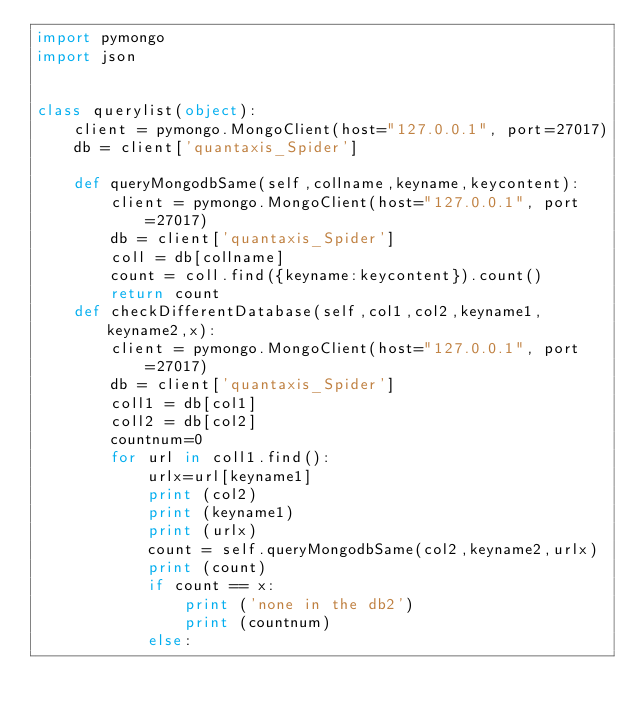<code> <loc_0><loc_0><loc_500><loc_500><_Python_>import pymongo
import json


class querylist(object):
    client = pymongo.MongoClient(host="127.0.0.1", port=27017)
    db = client['quantaxis_Spider']
    
    def queryMongodbSame(self,collname,keyname,keycontent):
        client = pymongo.MongoClient(host="127.0.0.1", port=27017)
        db = client['quantaxis_Spider']
        coll = db[collname]
        count = coll.find({keyname:keycontent}).count()
        return count
    def checkDifferentDatabase(self,col1,col2,keyname1,keyname2,x):
        client = pymongo.MongoClient(host="127.0.0.1", port=27017)
        db = client['quantaxis_Spider']
        coll1 = db[col1]
        coll2 = db[col2]
        countnum=0
        for url in coll1.find():
            urlx=url[keyname1]
            print (col2)
            print (keyname1)
            print (urlx)
            count = self.queryMongodbSame(col2,keyname2,urlx)
            print (count)
            if count == x:
                print ('none in the db2')
                print (countnum)
            else:</code> 